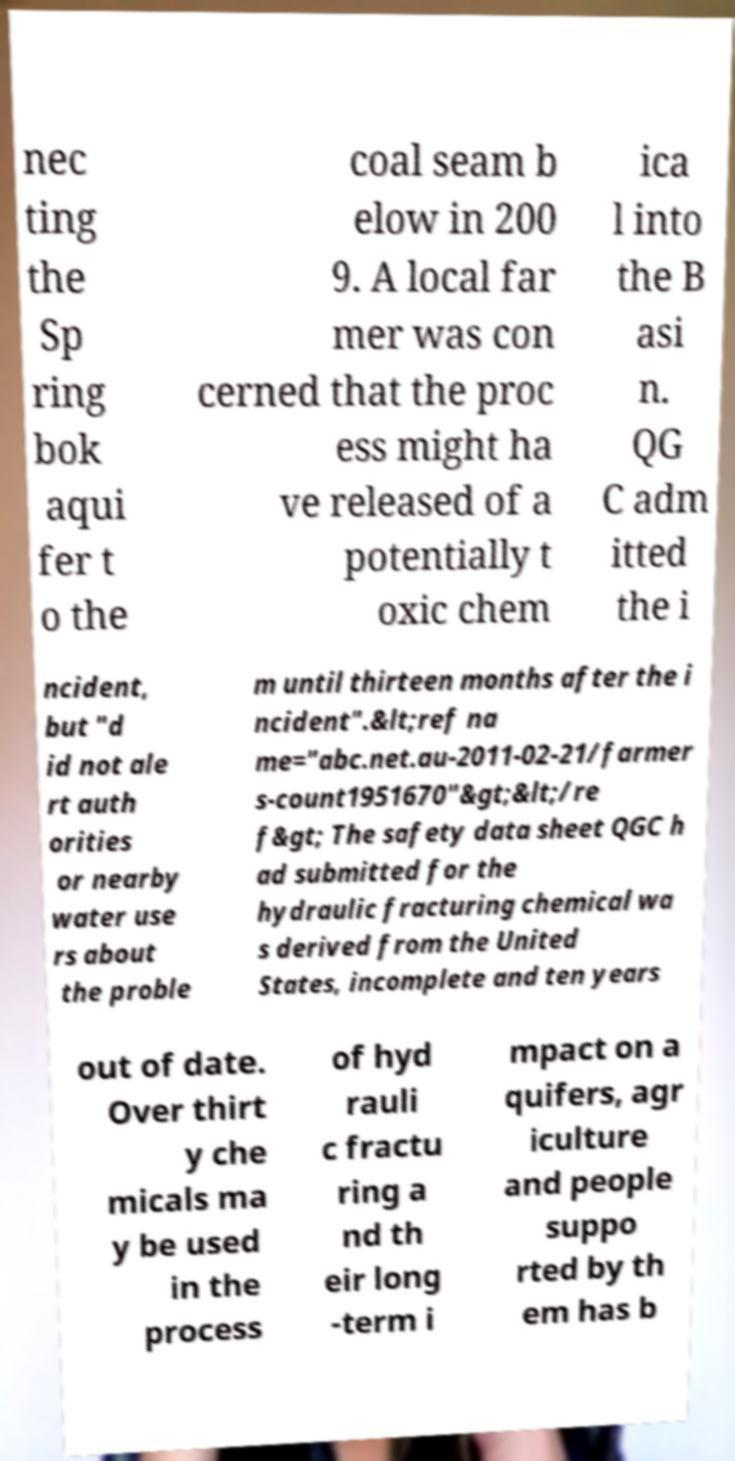Can you accurately transcribe the text from the provided image for me? nec ting the Sp ring bok aqui fer t o the coal seam b elow in 200 9. A local far mer was con cerned that the proc ess might ha ve released of a potentially t oxic chem ica l into the B asi n. QG C adm itted the i ncident, but "d id not ale rt auth orities or nearby water use rs about the proble m until thirteen months after the i ncident".&lt;ref na me="abc.net.au-2011-02-21/farmer s-count1951670"&gt;&lt;/re f&gt; The safety data sheet QGC h ad submitted for the hydraulic fracturing chemical wa s derived from the United States, incomplete and ten years out of date. Over thirt y che micals ma y be used in the process of hyd rauli c fractu ring a nd th eir long -term i mpact on a quifers, agr iculture and people suppo rted by th em has b 